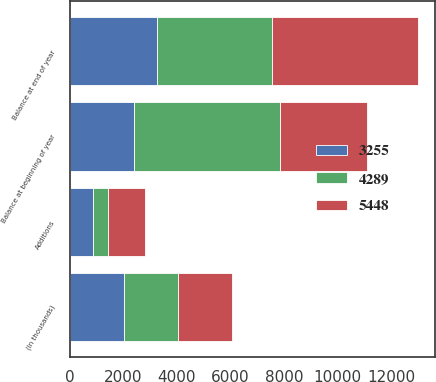Convert chart. <chart><loc_0><loc_0><loc_500><loc_500><stacked_bar_chart><ecel><fcel>(In thousands)<fcel>Balance at beginning of year<fcel>Additions<fcel>Balance at end of year<nl><fcel>4289<fcel>2016<fcel>5448<fcel>542<fcel>4289<nl><fcel>5448<fcel>2015<fcel>3255<fcel>1407<fcel>5448<nl><fcel>3255<fcel>2014<fcel>2385<fcel>870<fcel>3255<nl></chart> 